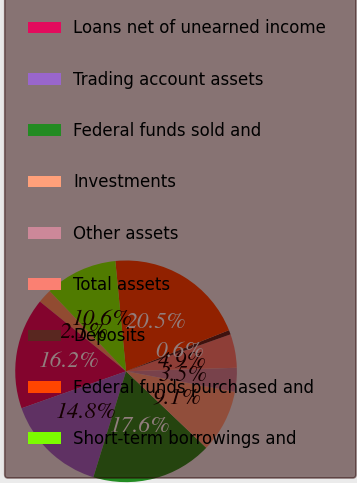Convert chart. <chart><loc_0><loc_0><loc_500><loc_500><pie_chart><fcel>Cash and deposits with banks<fcel>Loans net of unearned income<fcel>Trading account assets<fcel>Federal funds sold and<fcel>Investments<fcel>Other assets<fcel>Total assets<fcel>Deposits<fcel>Federal funds purchased and<fcel>Short-term borrowings and<nl><fcel>2.06%<fcel>16.24%<fcel>14.82%<fcel>17.65%<fcel>9.15%<fcel>3.48%<fcel>4.9%<fcel>0.64%<fcel>20.49%<fcel>10.57%<nl></chart> 